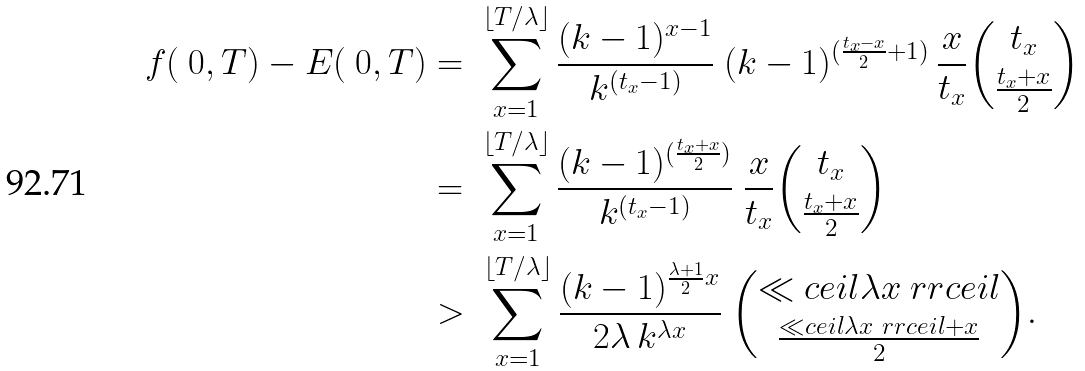<formula> <loc_0><loc_0><loc_500><loc_500>f ( \ 0 , T ) - E ( \ 0 , T ) & = \ \sum _ { x = 1 } ^ { \lfloor T / \lambda \rfloor } \frac { ( k - 1 ) ^ { x - 1 } } { k ^ { ( t _ { x } - 1 ) } } \ ( k - 1 ) ^ { ( \frac { t _ { x } - x } { 2 } + 1 ) } \, \frac { x } { t _ { x } } \binom { t _ { x } } { \frac { t _ { x } + x } { 2 } } \\ & = \ \sum _ { x = 1 } ^ { \lfloor T / \lambda \rfloor } \frac { ( k - 1 ) ^ { ( \frac { t _ { x } + x } { 2 } ) } } { k ^ { ( t _ { x } - 1 ) } } \ \frac { x } { t _ { x } } \binom { t _ { x } } { \frac { t _ { x } + x } { 2 } } \\ & > \ \sum _ { x = 1 } ^ { \lfloor T / \lambda \rfloor } \frac { ( k - 1 ) ^ { \frac { \lambda + 1 } { 2 } x } } { 2 \lambda \, k ^ { \lambda x } } \ \binom { \ll c e i l \lambda x \ r r c e i l } { \frac { \ll c e i l \lambda x \ r r c e i l + x } { 2 } } .</formula> 